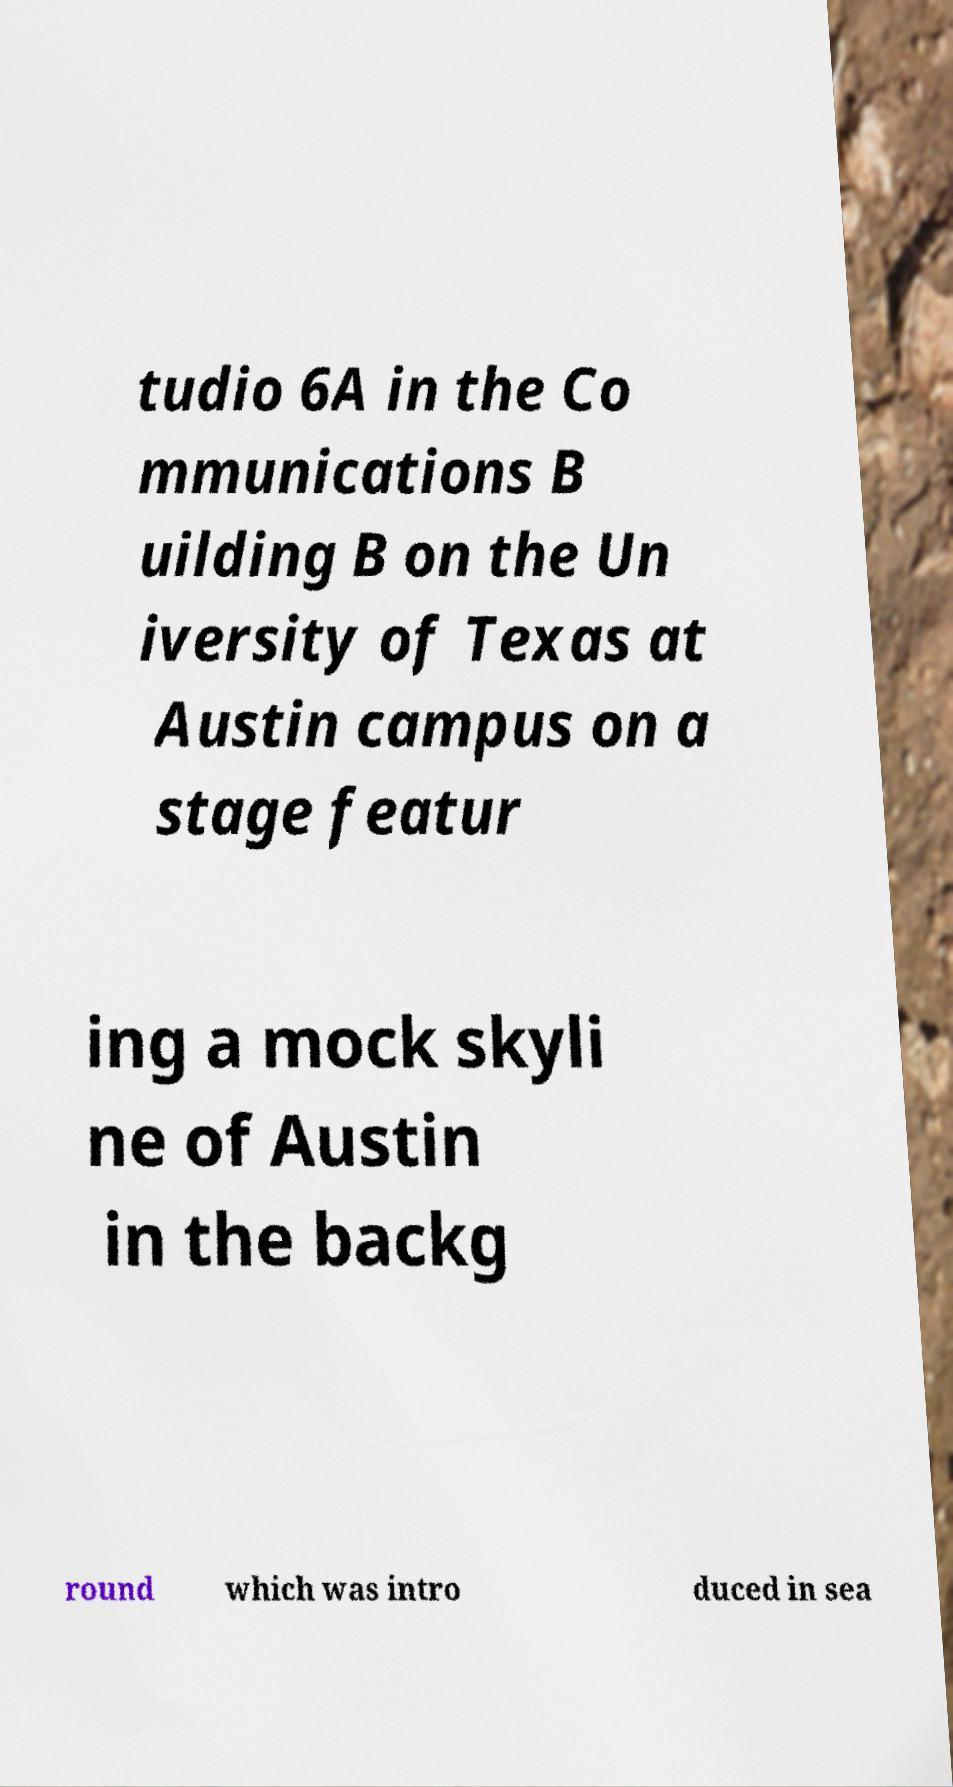Please identify and transcribe the text found in this image. tudio 6A in the Co mmunications B uilding B on the Un iversity of Texas at Austin campus on a stage featur ing a mock skyli ne of Austin in the backg round which was intro duced in sea 